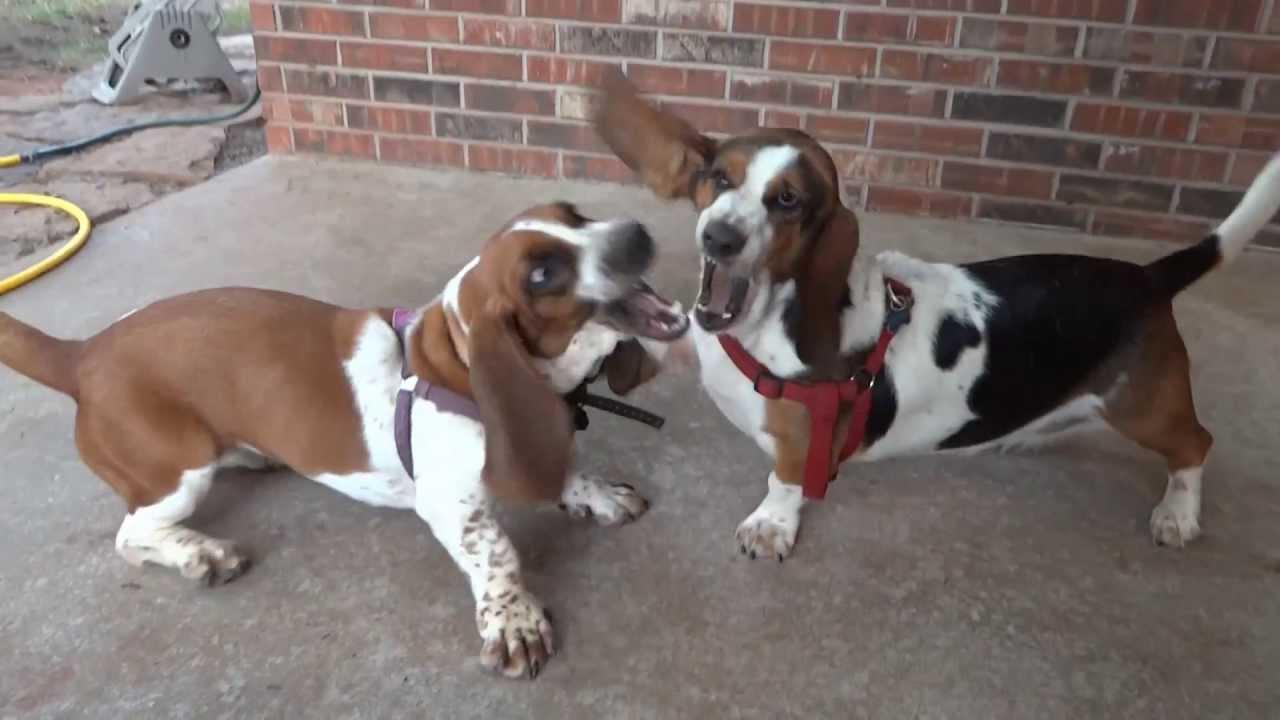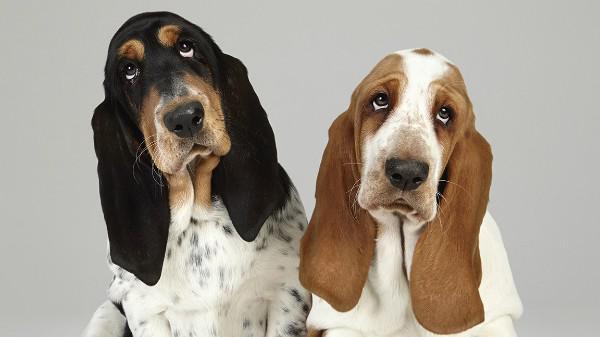The first image is the image on the left, the second image is the image on the right. Analyze the images presented: Is the assertion "One of the image shows only basset hounds, while the other shows a human with at least one basset hound." valid? Answer yes or no. No. The first image is the image on the left, the second image is the image on the right. Considering the images on both sides, is "The right image shows side-by-side basset hounds posed in the grass, and the left image shows one human posed in the grass with at least one basset hound." valid? Answer yes or no. No. 